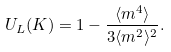<formula> <loc_0><loc_0><loc_500><loc_500>U _ { L } ( K ) = 1 - \frac { \langle m ^ { 4 } \rangle } { 3 \langle m ^ { 2 } \rangle ^ { 2 } } .</formula> 